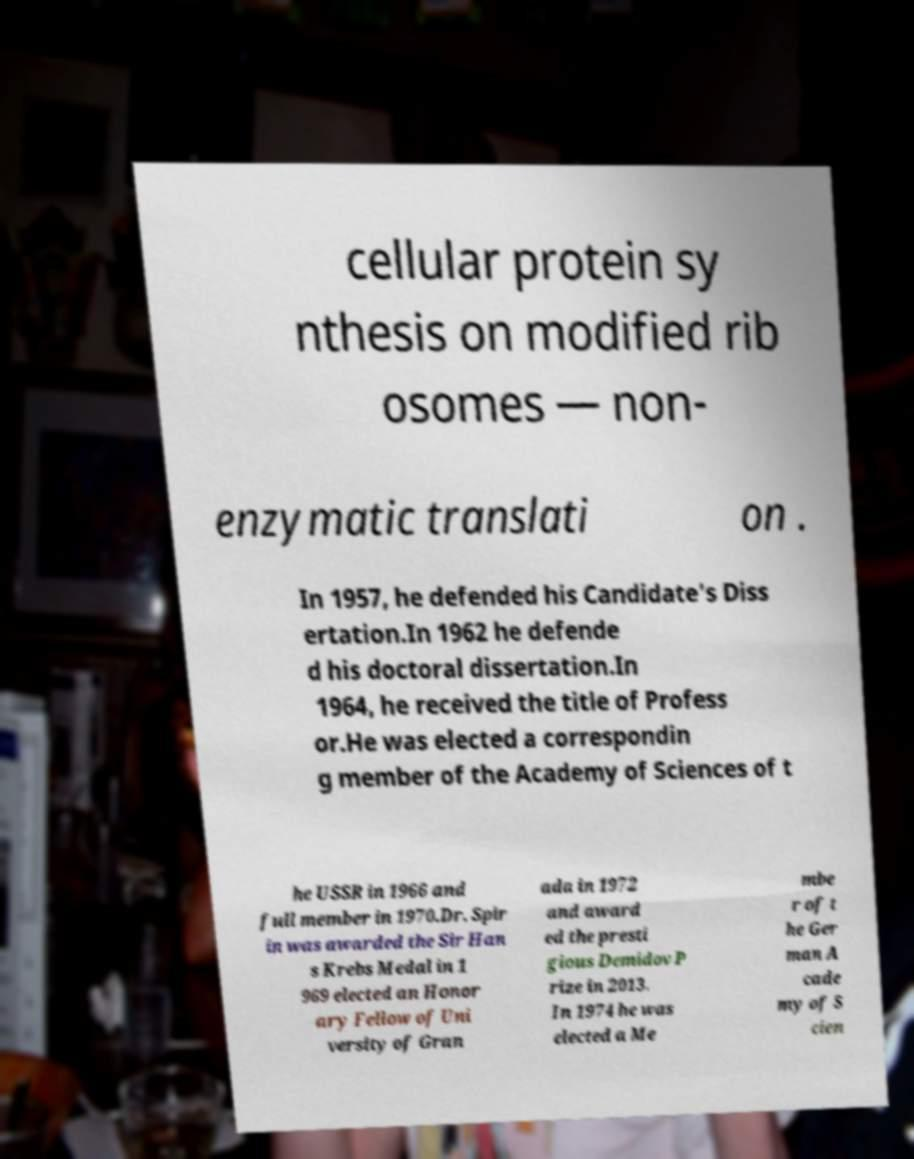I need the written content from this picture converted into text. Can you do that? cellular protein sy nthesis on modified rib osomes — non- enzymatic translati on . In 1957, he defended his Candidate's Diss ertation.In 1962 he defende d his doctoral dissertation.In 1964, he received the title of Profess or.He was elected a correspondin g member of the Academy of Sciences of t he USSR in 1966 and full member in 1970.Dr. Spir in was awarded the Sir Han s Krebs Medal in 1 969 elected an Honor ary Fellow of Uni versity of Gran ada in 1972 and award ed the presti gious Demidov P rize in 2013. In 1974 he was elected a Me mbe r of t he Ger man A cade my of S cien 